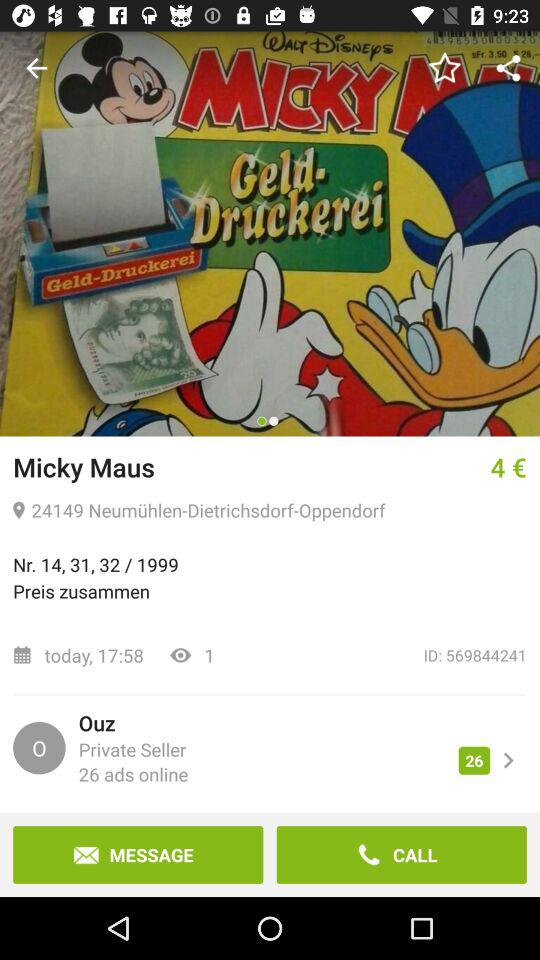How many ads does the private seller have online?
Answer the question using a single word or phrase. 26 